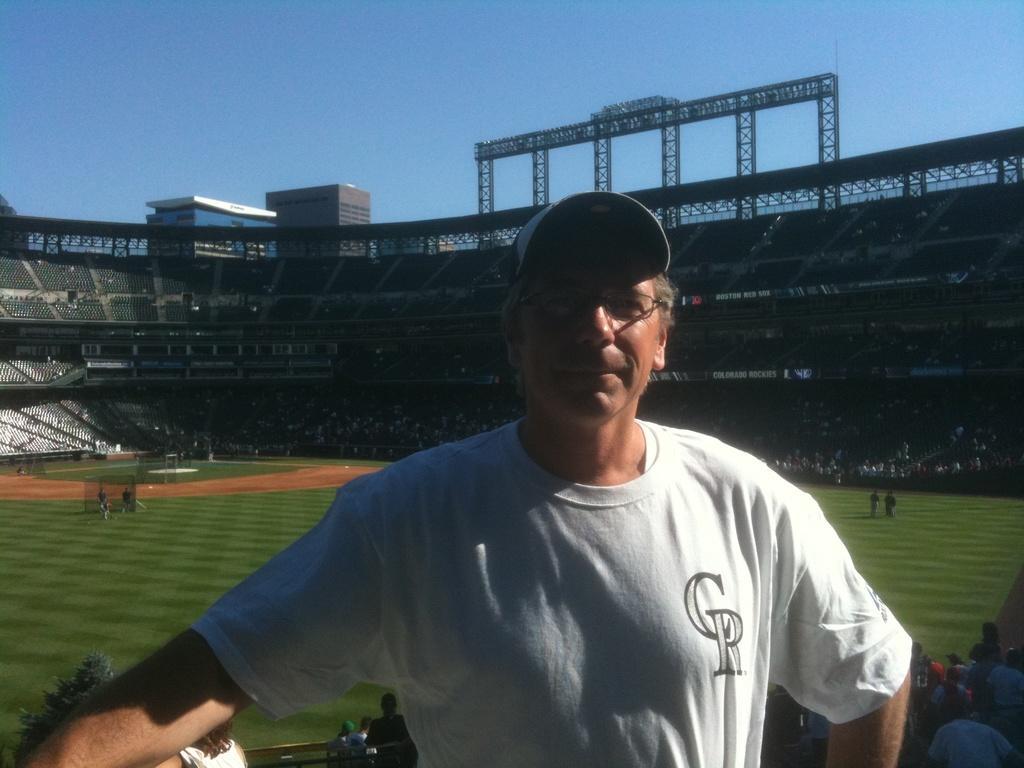Describe this image in one or two sentences. In the image we can see there is a man standing and he is wearing cap. There are other people sitting on the chairs and there is a ground covered with grass. There are people standing on the ground and behind there are people sitting in the pavilion. There is clear sky on the top and there are buildings at the back. 